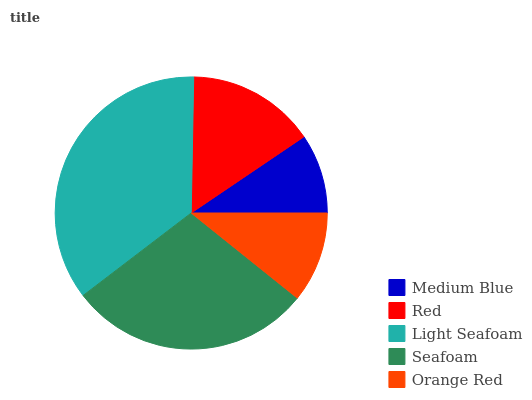Is Medium Blue the minimum?
Answer yes or no. Yes. Is Light Seafoam the maximum?
Answer yes or no. Yes. Is Red the minimum?
Answer yes or no. No. Is Red the maximum?
Answer yes or no. No. Is Red greater than Medium Blue?
Answer yes or no. Yes. Is Medium Blue less than Red?
Answer yes or no. Yes. Is Medium Blue greater than Red?
Answer yes or no. No. Is Red less than Medium Blue?
Answer yes or no. No. Is Red the high median?
Answer yes or no. Yes. Is Red the low median?
Answer yes or no. Yes. Is Medium Blue the high median?
Answer yes or no. No. Is Medium Blue the low median?
Answer yes or no. No. 